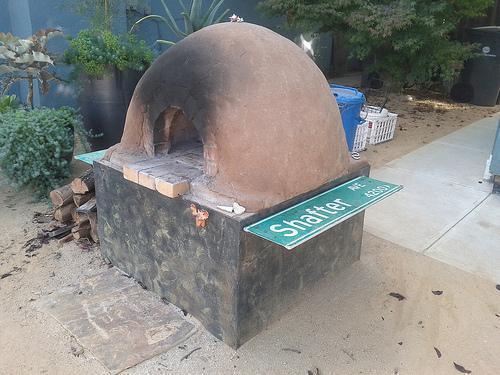How many street signs are there?
Give a very brief answer. 1. 